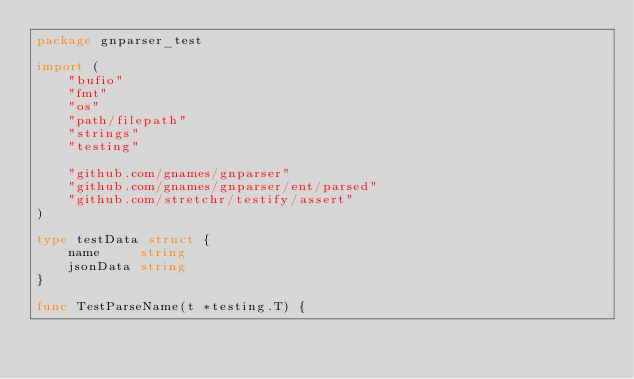Convert code to text. <code><loc_0><loc_0><loc_500><loc_500><_Go_>package gnparser_test

import (
	"bufio"
	"fmt"
	"os"
	"path/filepath"
	"strings"
	"testing"

	"github.com/gnames/gnparser"
	"github.com/gnames/gnparser/ent/parsed"
	"github.com/stretchr/testify/assert"
)

type testData struct {
	name     string
	jsonData string
}

func TestParseName(t *testing.T) {</code> 